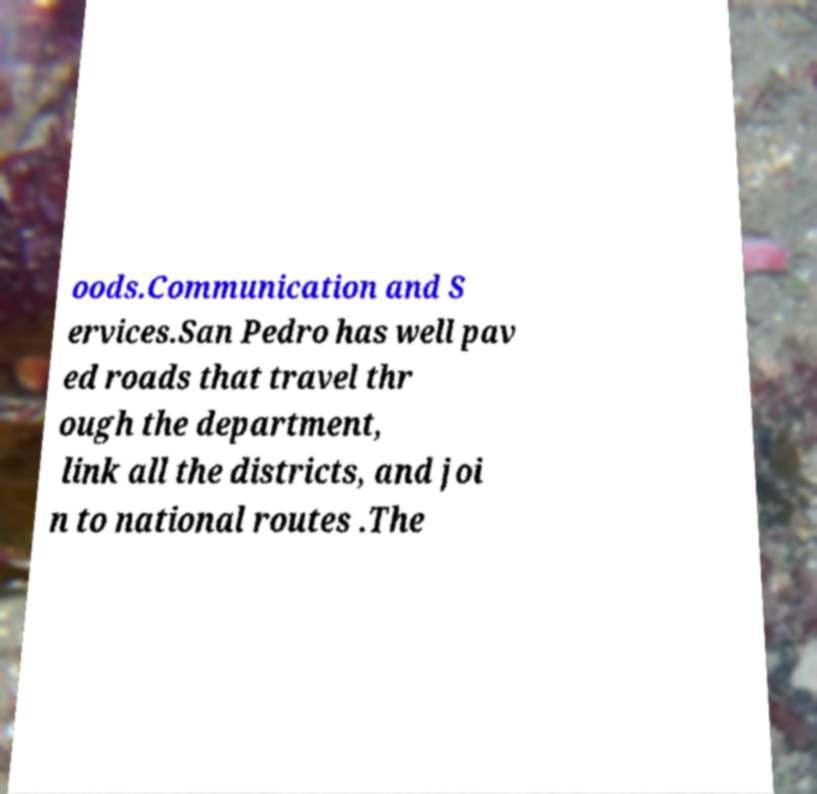What messages or text are displayed in this image? I need them in a readable, typed format. oods.Communication and S ervices.San Pedro has well pav ed roads that travel thr ough the department, link all the districts, and joi n to national routes .The 